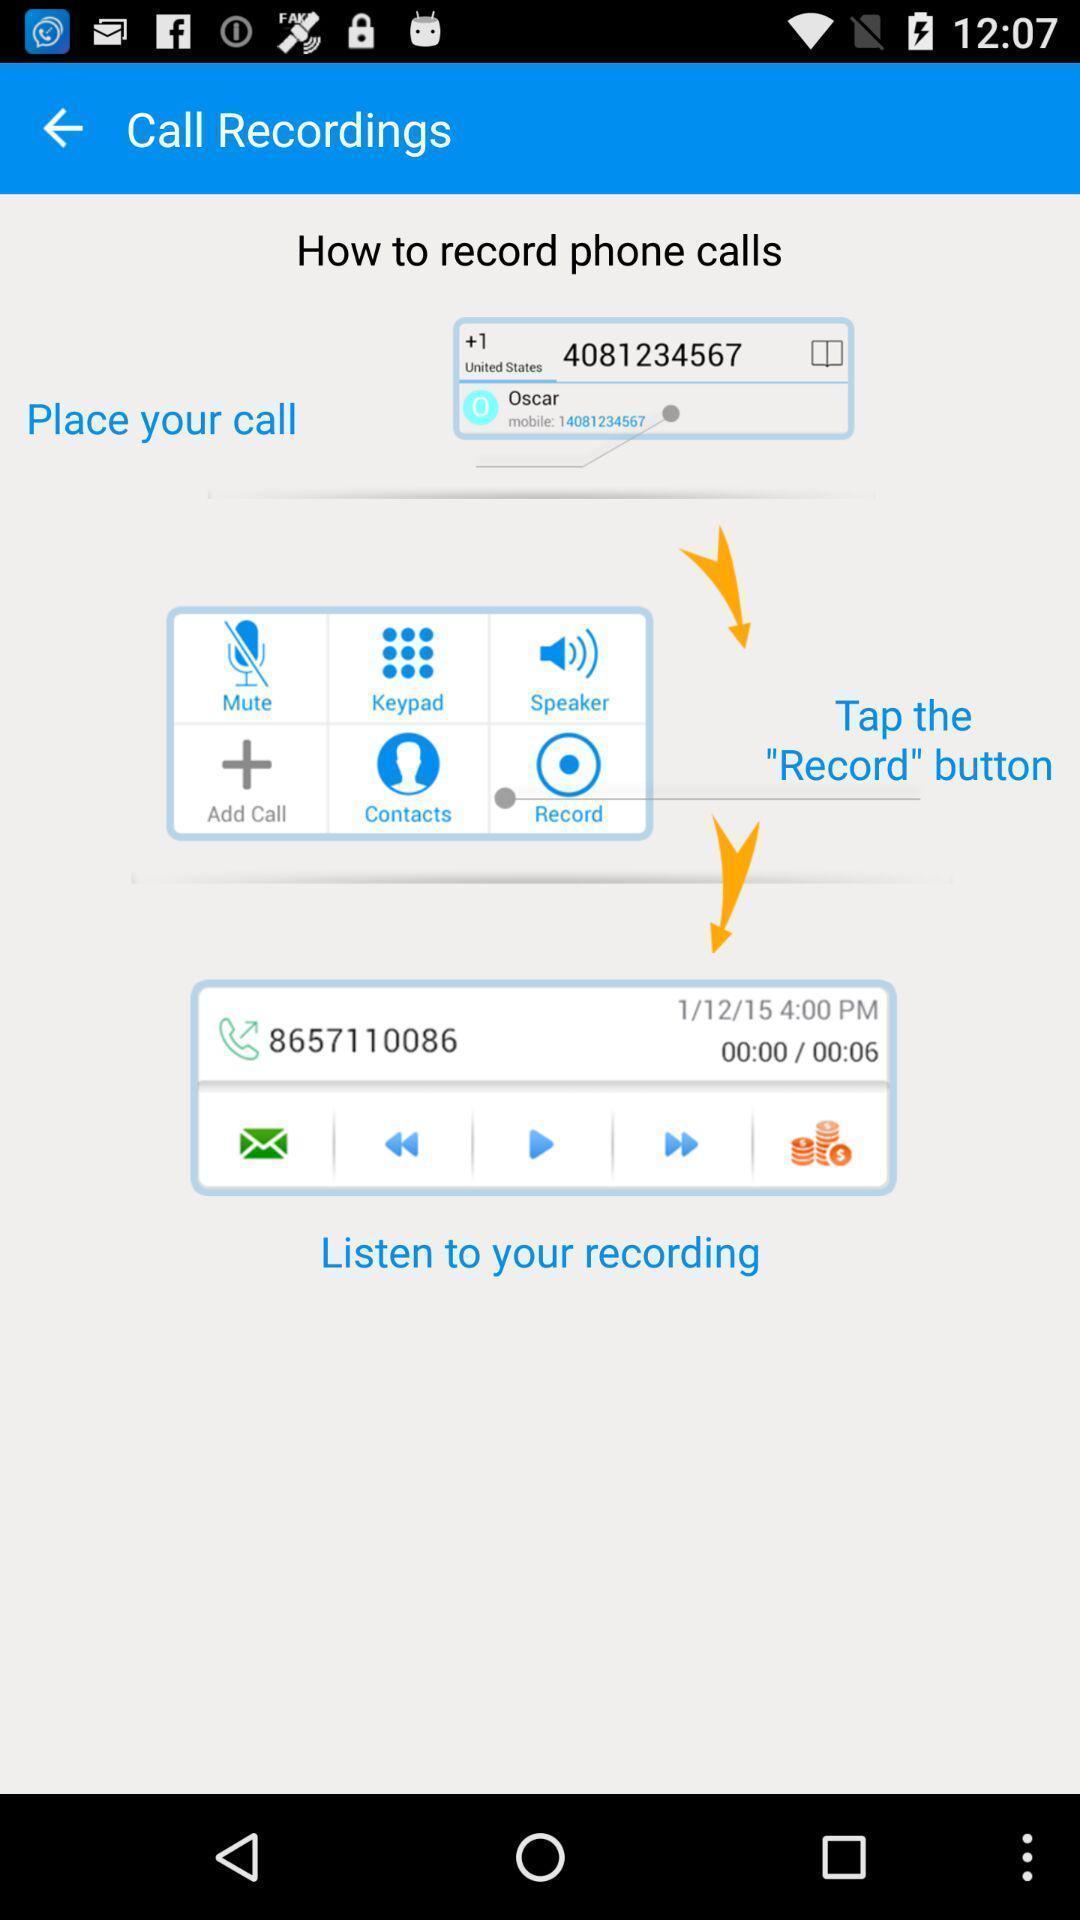Explain the elements present in this screenshot. Page showing information of call recordings. 